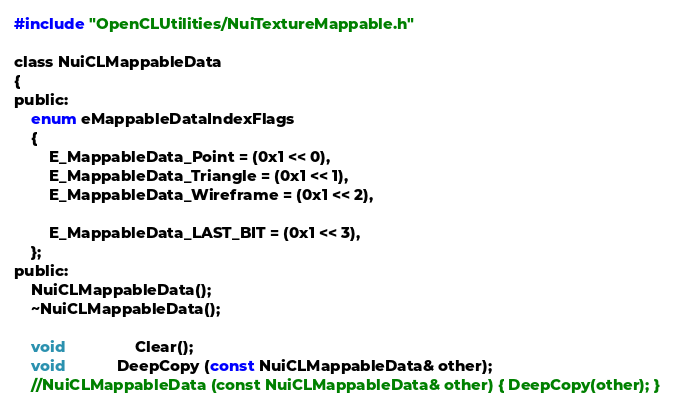Convert code to text. <code><loc_0><loc_0><loc_500><loc_500><_C_>#include "OpenCLUtilities/NuiTextureMappable.h"

class NuiCLMappableData
{
public:
	enum eMappableDataIndexFlags
	{
		E_MappableData_Point = (0x1 << 0),
		E_MappableData_Triangle = (0x1 << 1),
		E_MappableData_Wireframe = (0x1 << 2),

		E_MappableData_LAST_BIT = (0x1 << 3),
	};
public:
	NuiCLMappableData();
	~NuiCLMappableData();

	void				Clear();
	void			DeepCopy (const NuiCLMappableData& other);
	//NuiCLMappableData (const NuiCLMappableData& other) { DeepCopy(other); }</code> 